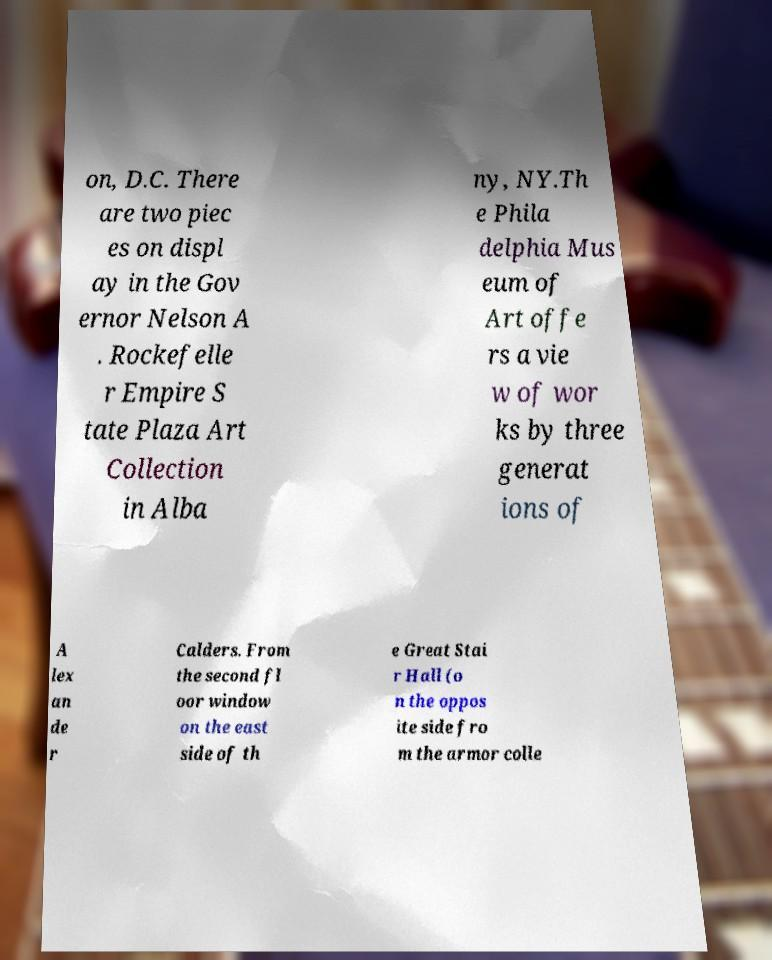There's text embedded in this image that I need extracted. Can you transcribe it verbatim? on, D.C. There are two piec es on displ ay in the Gov ernor Nelson A . Rockefelle r Empire S tate Plaza Art Collection in Alba ny, NY.Th e Phila delphia Mus eum of Art offe rs a vie w of wor ks by three generat ions of A lex an de r Calders. From the second fl oor window on the east side of th e Great Stai r Hall (o n the oppos ite side fro m the armor colle 